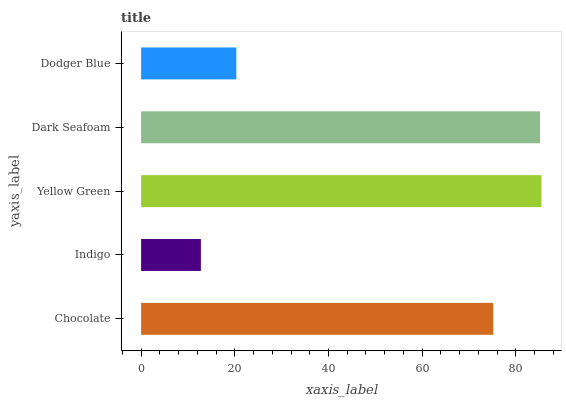Is Indigo the minimum?
Answer yes or no. Yes. Is Yellow Green the maximum?
Answer yes or no. Yes. Is Yellow Green the minimum?
Answer yes or no. No. Is Indigo the maximum?
Answer yes or no. No. Is Yellow Green greater than Indigo?
Answer yes or no. Yes. Is Indigo less than Yellow Green?
Answer yes or no. Yes. Is Indigo greater than Yellow Green?
Answer yes or no. No. Is Yellow Green less than Indigo?
Answer yes or no. No. Is Chocolate the high median?
Answer yes or no. Yes. Is Chocolate the low median?
Answer yes or no. Yes. Is Dark Seafoam the high median?
Answer yes or no. No. Is Indigo the low median?
Answer yes or no. No. 